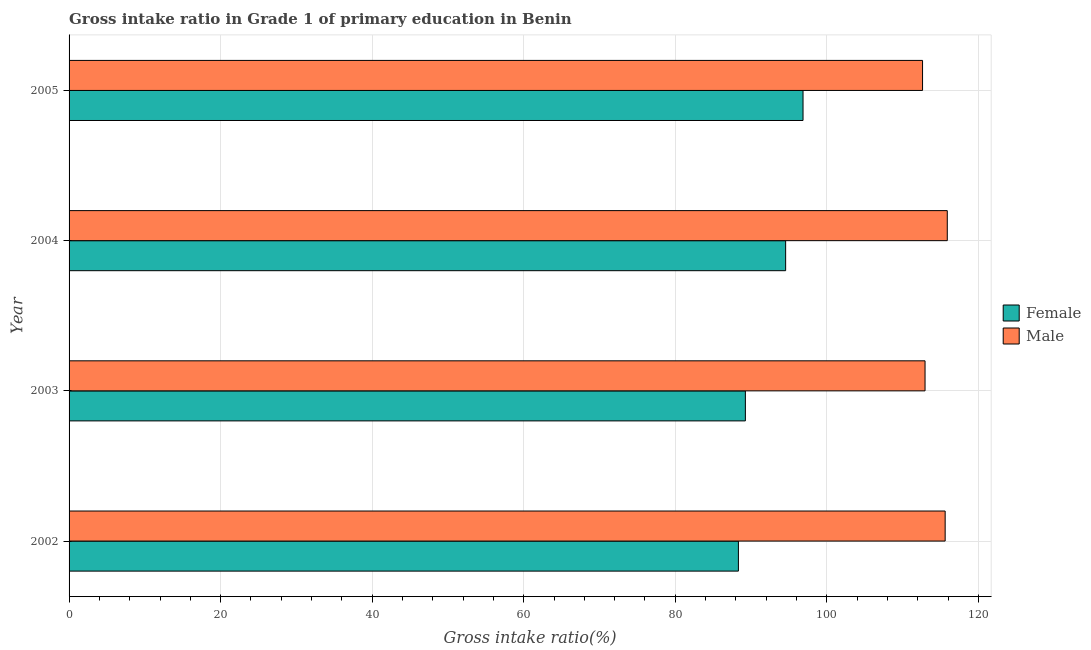How many different coloured bars are there?
Keep it short and to the point. 2. Are the number of bars per tick equal to the number of legend labels?
Provide a succinct answer. Yes. How many bars are there on the 1st tick from the bottom?
Offer a terse response. 2. What is the label of the 1st group of bars from the top?
Give a very brief answer. 2005. What is the gross intake ratio(female) in 2003?
Your answer should be compact. 89.25. Across all years, what is the maximum gross intake ratio(male)?
Offer a terse response. 115.9. Across all years, what is the minimum gross intake ratio(female)?
Keep it short and to the point. 88.33. In which year was the gross intake ratio(male) minimum?
Offer a very short reply. 2005. What is the total gross intake ratio(male) in the graph?
Keep it short and to the point. 457.1. What is the difference between the gross intake ratio(female) in 2003 and that in 2005?
Offer a terse response. -7.61. What is the difference between the gross intake ratio(female) in 2003 and the gross intake ratio(male) in 2004?
Your answer should be very brief. -26.65. What is the average gross intake ratio(male) per year?
Give a very brief answer. 114.28. In the year 2002, what is the difference between the gross intake ratio(male) and gross intake ratio(female)?
Make the answer very short. 27.28. What is the difference between the highest and the second highest gross intake ratio(female)?
Provide a succinct answer. 2.3. What is the difference between the highest and the lowest gross intake ratio(male)?
Your answer should be very brief. 3.26. Is the sum of the gross intake ratio(female) in 2002 and 2003 greater than the maximum gross intake ratio(male) across all years?
Keep it short and to the point. Yes. What does the 1st bar from the top in 2004 represents?
Keep it short and to the point. Male. How many bars are there?
Provide a short and direct response. 8. How many years are there in the graph?
Provide a succinct answer. 4. What is the difference between two consecutive major ticks on the X-axis?
Provide a succinct answer. 20. Does the graph contain any zero values?
Offer a terse response. No. How many legend labels are there?
Ensure brevity in your answer.  2. What is the title of the graph?
Your answer should be compact. Gross intake ratio in Grade 1 of primary education in Benin. Does "Largest city" appear as one of the legend labels in the graph?
Provide a succinct answer. No. What is the label or title of the X-axis?
Ensure brevity in your answer.  Gross intake ratio(%). What is the Gross intake ratio(%) in Female in 2002?
Give a very brief answer. 88.33. What is the Gross intake ratio(%) of Male in 2002?
Make the answer very short. 115.62. What is the Gross intake ratio(%) in Female in 2003?
Keep it short and to the point. 89.25. What is the Gross intake ratio(%) of Male in 2003?
Ensure brevity in your answer.  112.96. What is the Gross intake ratio(%) of Female in 2004?
Ensure brevity in your answer.  94.56. What is the Gross intake ratio(%) of Male in 2004?
Your answer should be compact. 115.9. What is the Gross intake ratio(%) in Female in 2005?
Offer a very short reply. 96.86. What is the Gross intake ratio(%) of Male in 2005?
Your answer should be compact. 112.63. Across all years, what is the maximum Gross intake ratio(%) of Female?
Give a very brief answer. 96.86. Across all years, what is the maximum Gross intake ratio(%) in Male?
Provide a short and direct response. 115.9. Across all years, what is the minimum Gross intake ratio(%) of Female?
Provide a succinct answer. 88.33. Across all years, what is the minimum Gross intake ratio(%) of Male?
Ensure brevity in your answer.  112.63. What is the total Gross intake ratio(%) of Female in the graph?
Your response must be concise. 369. What is the total Gross intake ratio(%) in Male in the graph?
Offer a terse response. 457.1. What is the difference between the Gross intake ratio(%) in Female in 2002 and that in 2003?
Offer a terse response. -0.92. What is the difference between the Gross intake ratio(%) of Male in 2002 and that in 2003?
Ensure brevity in your answer.  2.65. What is the difference between the Gross intake ratio(%) of Female in 2002 and that in 2004?
Make the answer very short. -6.23. What is the difference between the Gross intake ratio(%) of Male in 2002 and that in 2004?
Ensure brevity in your answer.  -0.28. What is the difference between the Gross intake ratio(%) of Female in 2002 and that in 2005?
Your answer should be compact. -8.53. What is the difference between the Gross intake ratio(%) of Male in 2002 and that in 2005?
Provide a short and direct response. 2.98. What is the difference between the Gross intake ratio(%) of Female in 2003 and that in 2004?
Offer a terse response. -5.31. What is the difference between the Gross intake ratio(%) of Male in 2003 and that in 2004?
Keep it short and to the point. -2.93. What is the difference between the Gross intake ratio(%) in Female in 2003 and that in 2005?
Your answer should be very brief. -7.61. What is the difference between the Gross intake ratio(%) of Male in 2003 and that in 2005?
Your answer should be very brief. 0.33. What is the difference between the Gross intake ratio(%) of Female in 2004 and that in 2005?
Ensure brevity in your answer.  -2.3. What is the difference between the Gross intake ratio(%) in Male in 2004 and that in 2005?
Your answer should be very brief. 3.26. What is the difference between the Gross intake ratio(%) in Female in 2002 and the Gross intake ratio(%) in Male in 2003?
Provide a short and direct response. -24.63. What is the difference between the Gross intake ratio(%) of Female in 2002 and the Gross intake ratio(%) of Male in 2004?
Provide a short and direct response. -27.56. What is the difference between the Gross intake ratio(%) in Female in 2002 and the Gross intake ratio(%) in Male in 2005?
Give a very brief answer. -24.3. What is the difference between the Gross intake ratio(%) in Female in 2003 and the Gross intake ratio(%) in Male in 2004?
Keep it short and to the point. -26.65. What is the difference between the Gross intake ratio(%) in Female in 2003 and the Gross intake ratio(%) in Male in 2005?
Give a very brief answer. -23.38. What is the difference between the Gross intake ratio(%) of Female in 2004 and the Gross intake ratio(%) of Male in 2005?
Your answer should be compact. -18.07. What is the average Gross intake ratio(%) of Female per year?
Provide a short and direct response. 92.25. What is the average Gross intake ratio(%) in Male per year?
Make the answer very short. 114.28. In the year 2002, what is the difference between the Gross intake ratio(%) in Female and Gross intake ratio(%) in Male?
Ensure brevity in your answer.  -27.28. In the year 2003, what is the difference between the Gross intake ratio(%) in Female and Gross intake ratio(%) in Male?
Provide a short and direct response. -23.71. In the year 2004, what is the difference between the Gross intake ratio(%) of Female and Gross intake ratio(%) of Male?
Your answer should be very brief. -21.33. In the year 2005, what is the difference between the Gross intake ratio(%) in Female and Gross intake ratio(%) in Male?
Offer a very short reply. -15.77. What is the ratio of the Gross intake ratio(%) of Female in 2002 to that in 2003?
Make the answer very short. 0.99. What is the ratio of the Gross intake ratio(%) in Male in 2002 to that in 2003?
Provide a succinct answer. 1.02. What is the ratio of the Gross intake ratio(%) in Female in 2002 to that in 2004?
Your response must be concise. 0.93. What is the ratio of the Gross intake ratio(%) in Female in 2002 to that in 2005?
Keep it short and to the point. 0.91. What is the ratio of the Gross intake ratio(%) of Male in 2002 to that in 2005?
Provide a succinct answer. 1.03. What is the ratio of the Gross intake ratio(%) of Female in 2003 to that in 2004?
Offer a very short reply. 0.94. What is the ratio of the Gross intake ratio(%) of Male in 2003 to that in 2004?
Your answer should be compact. 0.97. What is the ratio of the Gross intake ratio(%) of Female in 2003 to that in 2005?
Your answer should be very brief. 0.92. What is the ratio of the Gross intake ratio(%) of Male in 2003 to that in 2005?
Give a very brief answer. 1. What is the ratio of the Gross intake ratio(%) of Female in 2004 to that in 2005?
Provide a succinct answer. 0.98. What is the ratio of the Gross intake ratio(%) in Male in 2004 to that in 2005?
Offer a very short reply. 1.03. What is the difference between the highest and the second highest Gross intake ratio(%) of Female?
Give a very brief answer. 2.3. What is the difference between the highest and the second highest Gross intake ratio(%) of Male?
Provide a short and direct response. 0.28. What is the difference between the highest and the lowest Gross intake ratio(%) in Female?
Keep it short and to the point. 8.53. What is the difference between the highest and the lowest Gross intake ratio(%) of Male?
Give a very brief answer. 3.26. 